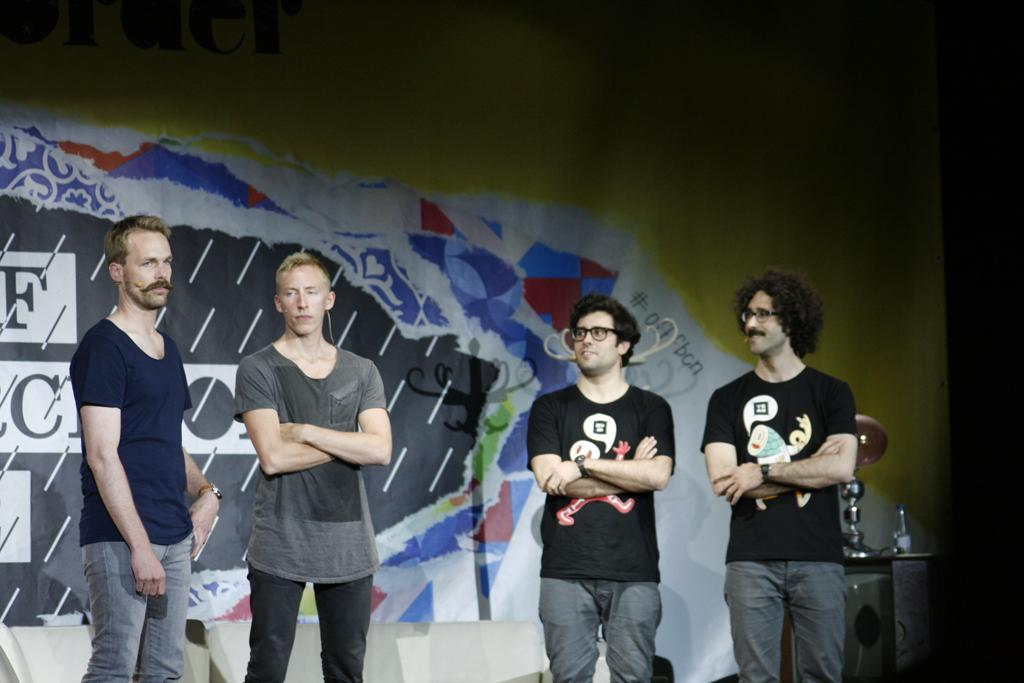How many people are present in the image? There are four people standing in the image. What can be seen on the right side of the image? There is a stand on the right side of the image. What is placed on the stand? There are things placed on the stand. What is visible in the background of the image? There is a board visible in the background of the image. What type of drum can be heard playing in the image? There is no drum present or audible in the image. 